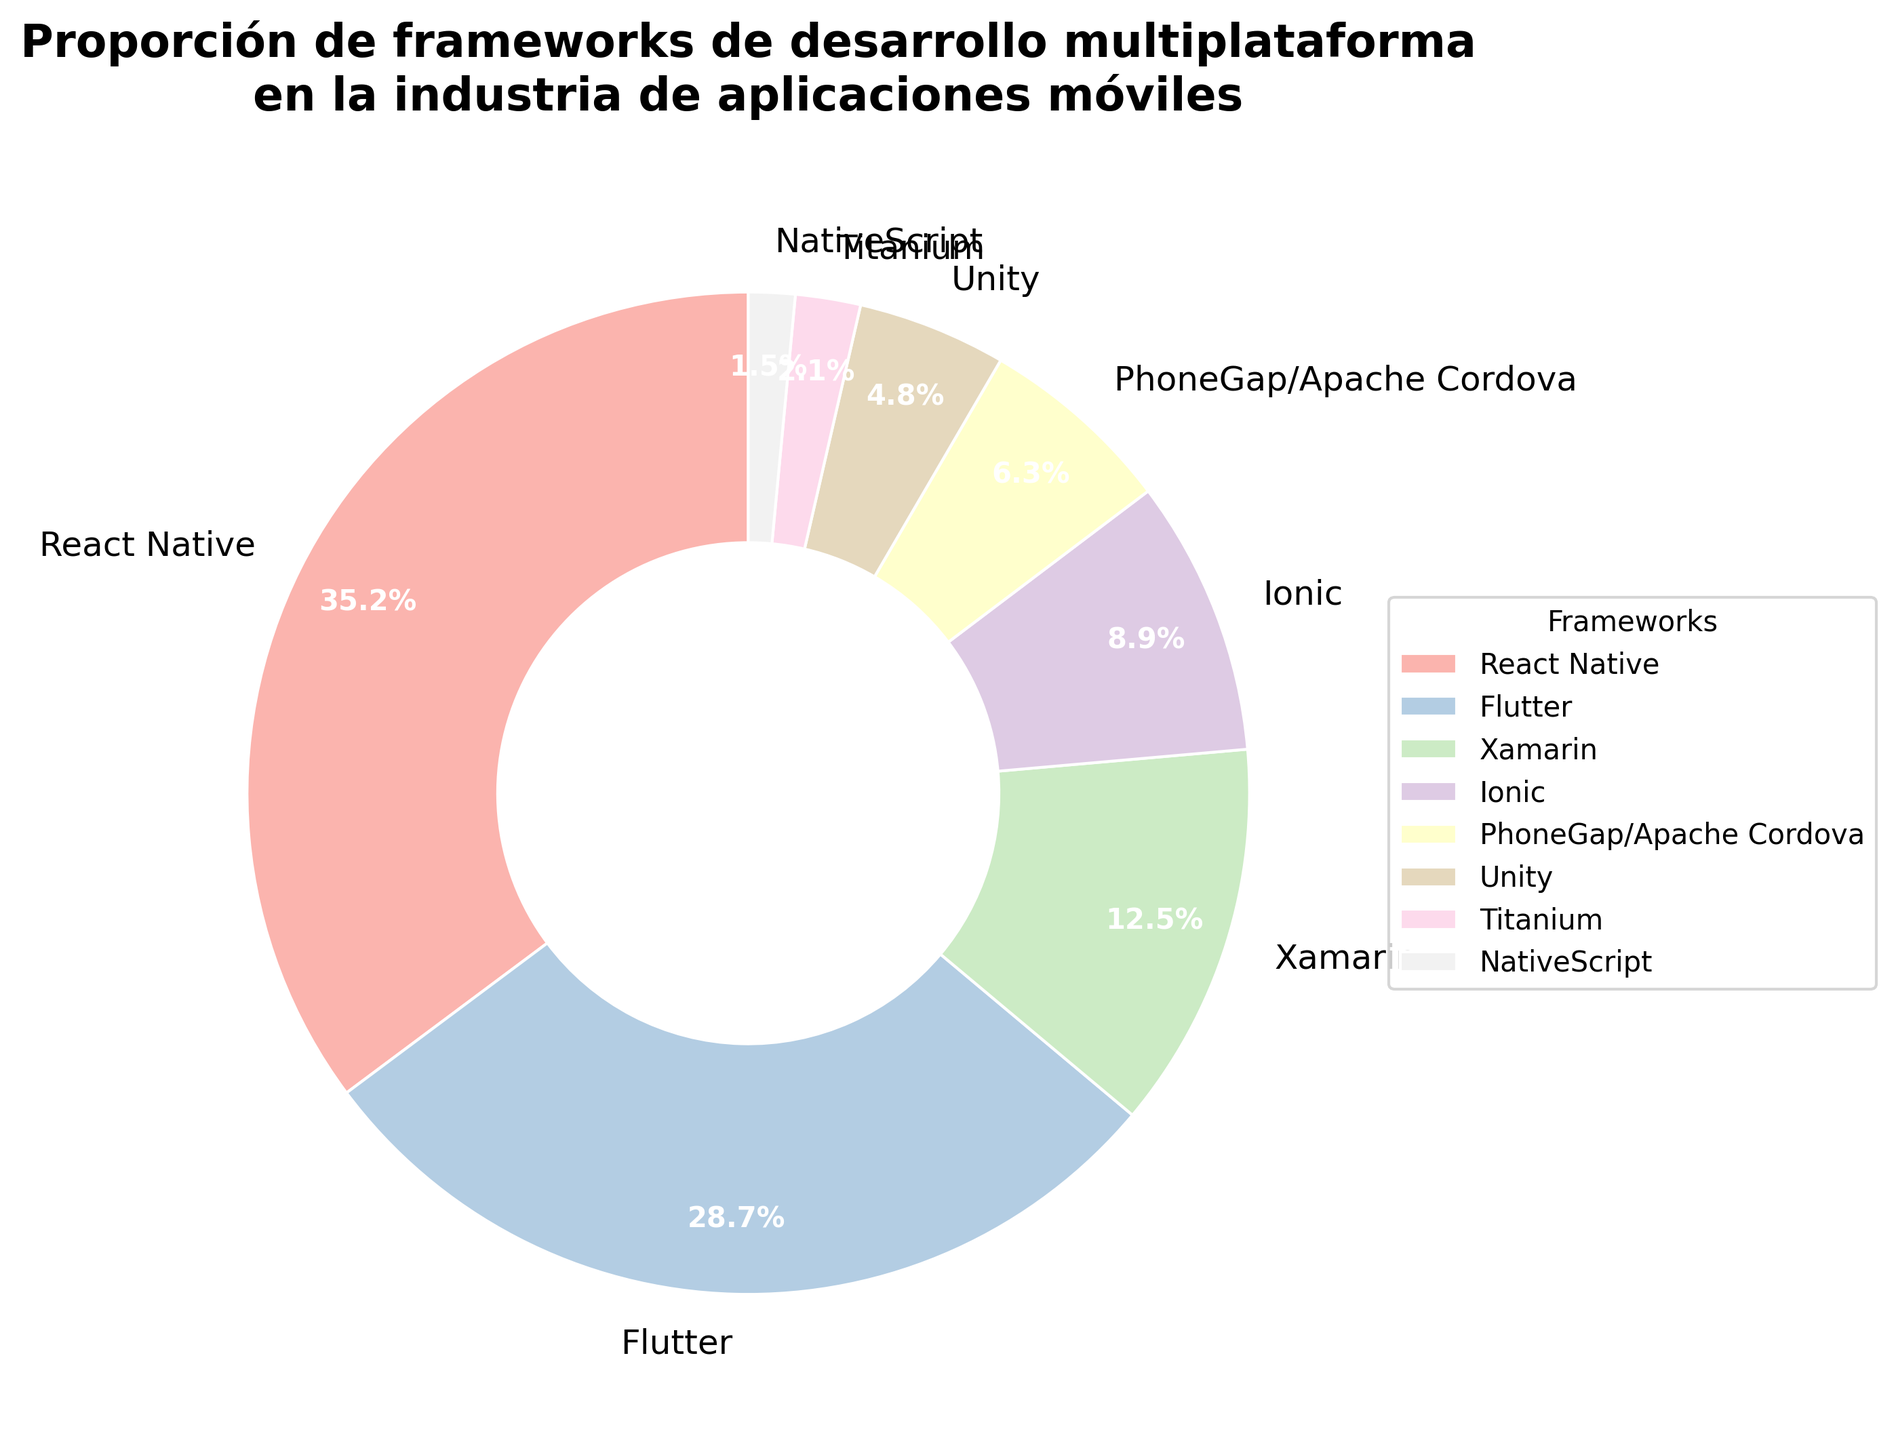what is the framework with the largest proportion? The framework with the largest proportion can be identified as the one with the highest percentage on the pie chart. By looking at the figure, React Native has 35.2%, which is higher than any other framework.
Answer: React Native ¿Cuál es la diferencia de porcentaje entre React Native y Flutter? Para encontrar la diferencia de porcentaje entre React Native y Flutter, restamos el porcentaje de Flutter del porcentaje de React Native: 35.2% - 28.7% = 6.5%.
Answer: 6.5% ¿Qué framework tiene la menor proporción en la industria de aplicaciones móviles? Para determinar qué framework tiene la menor proporción, buscamos el que tenga el porcentaje más bajo en el gráfico. NativeScript tiene el valor más bajo con 1.5%.
Answer: NativeScript ¿Cuántos frameworks tienen una proporción mayor al 10%? Para determinar cuántos frameworks tienen una proporción mayor al 10%, observamos los porcentajes en el gráfico y contamos aquellos superiores a 10%: React Native (35.2%), Flutter (28.7%) y Xamarin (12.5%). Hay un total de tres.
Answer: 3 ¿Cuál es el porcentaje combinado de los frameworks Ionic y PhoneGap/Apache Cordova? Para encontrar el porcentaje combinado de Ionic y PhoneGap/Apache Cordova, sumamos sus porcentajes individuales: 8.9% + 6.3% = 15.2%.
Answer: 15.2% ¿Cuál es la posición de Unity en términos de porcentaje entre los frameworks de la lista? Para encontrar la posición de Unity, observamos los porcentajes del gráfico en orden descendente y vemos que Unity tiene 4.8%, situándolo en la quinta posición.
Answer: quinta ¿Es mayor la suma de los porcentajes de Xamarin e Ionic que la de PhoneGap/Apache Cordova y Unity? Para determinar esto, primero sumamos los porcentajes de Xamarin e Ionic (12.5% + 8.9% = 21.4%), y luego los de PhoneGap/Apache Cordova y Unity (6.3% + 4.8% = 11.1%). Comparamos ambas sumas y vemos que 21.4% es mayor que 11.1%.
Answer: Sí ¿Qué frameworks representan conjuntamente alrededor del 64% del mercado? Para encontrar los frameworks que juntos representan alrededor del 64% del mercado, sumamos los porcentajes empezando por los más altos hasta alcanzar aproximadamente el 64%. React Native (35.2%) y Flutter (28.7%) suman un total de 63.9%, que es aproximadamente 64%.
Answer: React Native y Flutter ¿Cuál es la diferencia de proporción entre el framework con el tercer mayor porcentaje y el framework con el cuarto mayor porcentaje? Observamos que el framework con el tercer mayor porcentaje es Xamarin (12.5%) y el cuarto es Ionic (8.9%). La diferencia es 12.5% - 8.9% = 3.6%.
Answer: 3.6% 